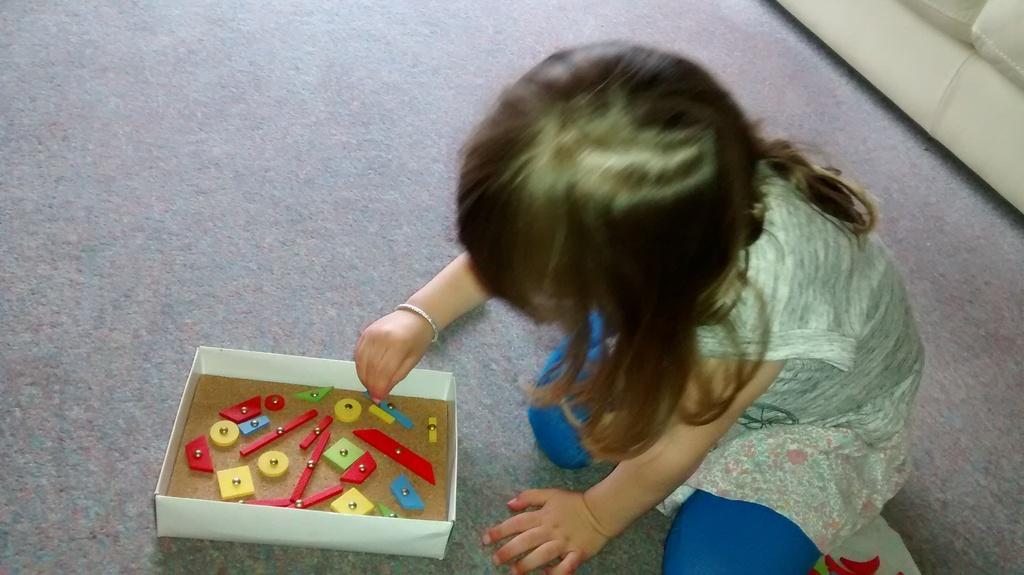Describe this image in one or two sentences. In this image there is a girl sitting on the carpet and playing with the toys , which are in the box, and in the background there is a couch on the carpet. 